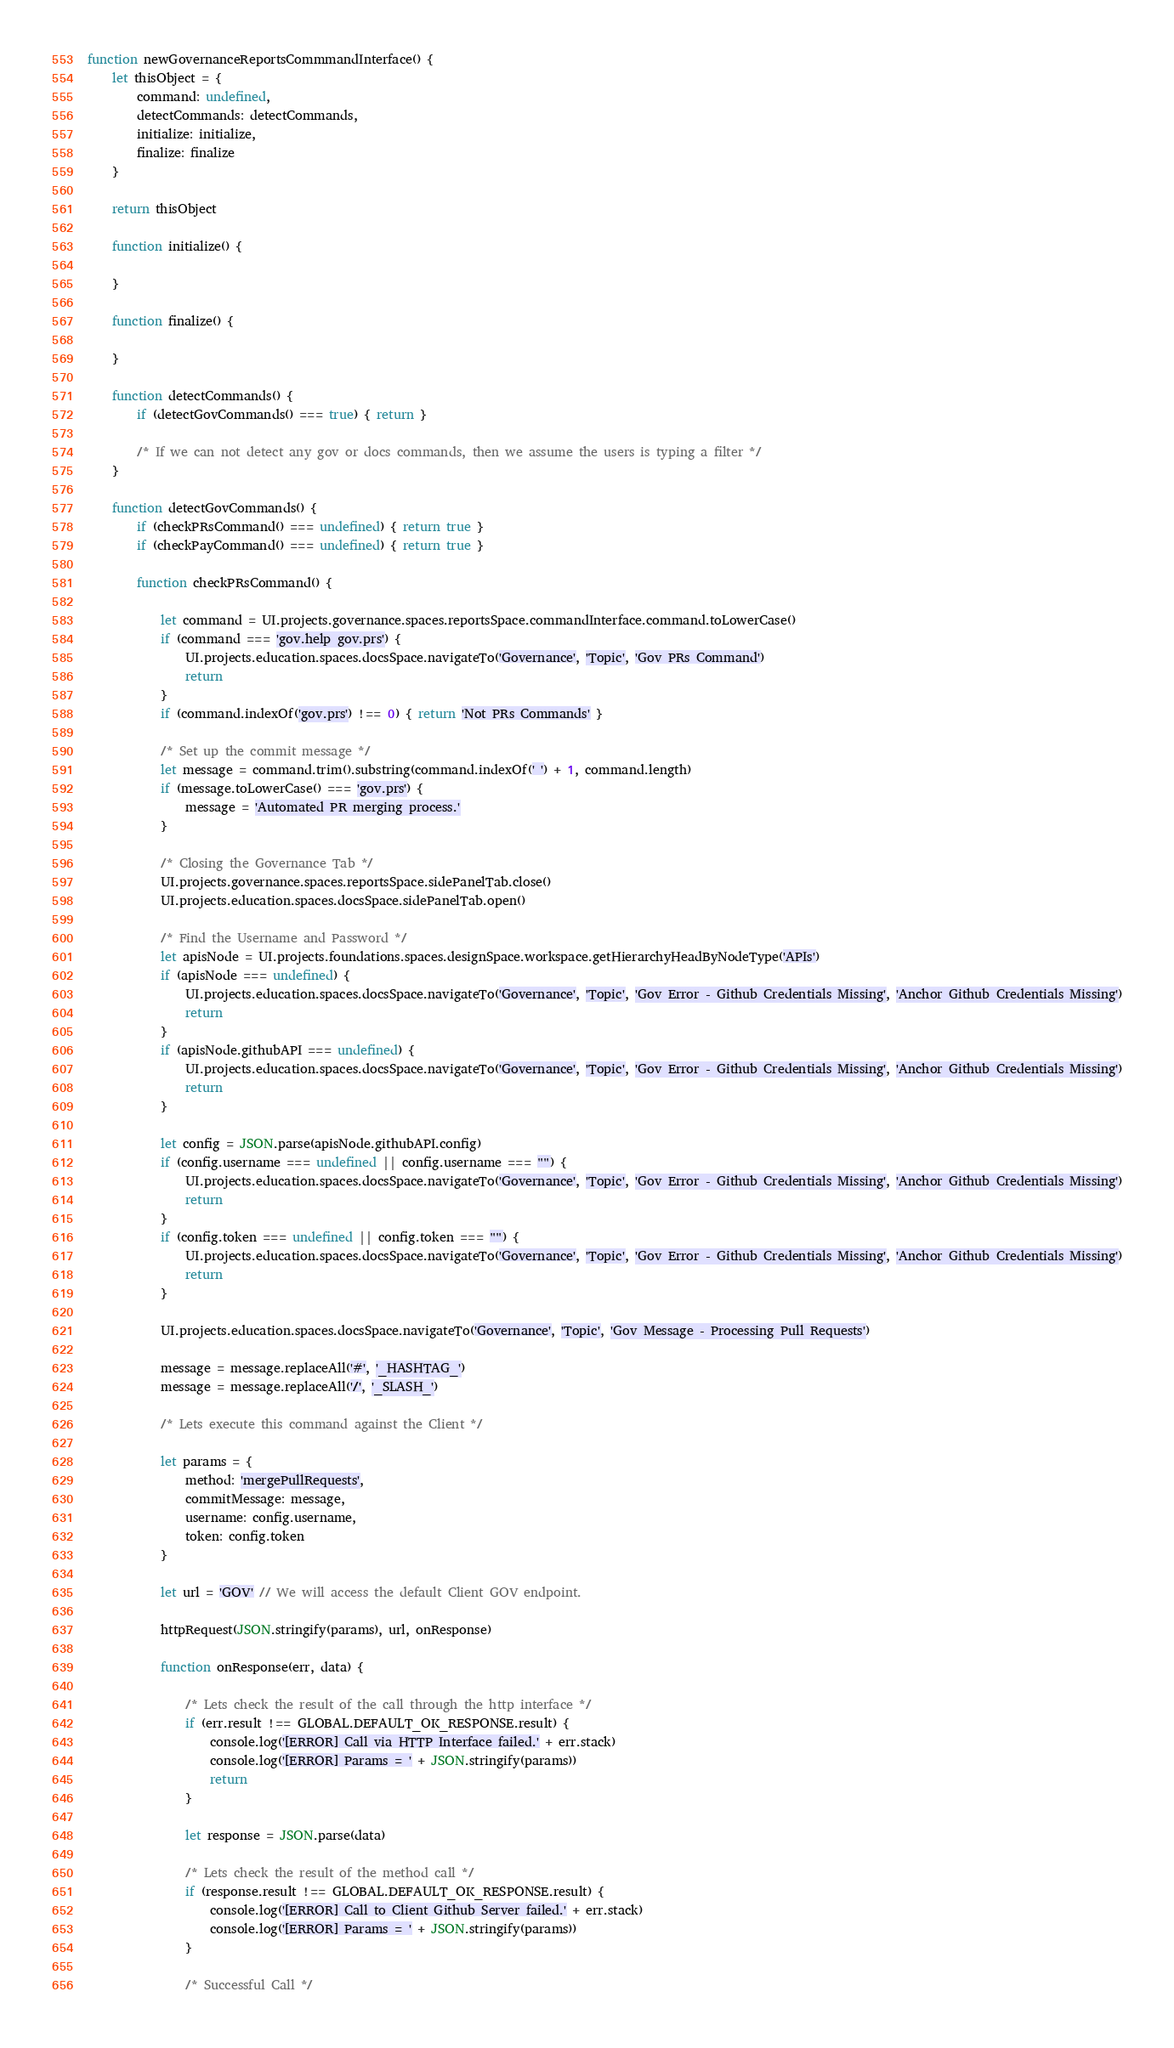<code> <loc_0><loc_0><loc_500><loc_500><_JavaScript_>function newGovernanceReportsCommmandInterface() {
    let thisObject = {
        command: undefined,
        detectCommands: detectCommands,
        initialize: initialize,
        finalize: finalize
    }

    return thisObject

    function initialize() {

    }

    function finalize() {

    }

    function detectCommands() {
        if (detectGovCommands() === true) { return }

        /* If we can not detect any gov or docs commands, then we assume the users is typing a filter */
    }

    function detectGovCommands() {
        if (checkPRsCommand() === undefined) { return true }
        if (checkPayCommand() === undefined) { return true }

        function checkPRsCommand() {

            let command = UI.projects.governance.spaces.reportsSpace.commandInterface.command.toLowerCase()
            if (command === 'gov.help gov.prs') {
                UI.projects.education.spaces.docsSpace.navigateTo('Governance', 'Topic', 'Gov PRs Command')
                return
            }
            if (command.indexOf('gov.prs') !== 0) { return 'Not PRs Commands' }

            /* Set up the commit message */
            let message = command.trim().substring(command.indexOf(' ') + 1, command.length)
            if (message.toLowerCase() === 'gov.prs') {
                message = 'Automated PR merging process.'
            }

            /* Closing the Governance Tab */
            UI.projects.governance.spaces.reportsSpace.sidePanelTab.close()
            UI.projects.education.spaces.docsSpace.sidePanelTab.open()

            /* Find the Username and Password */
            let apisNode = UI.projects.foundations.spaces.designSpace.workspace.getHierarchyHeadByNodeType('APIs')
            if (apisNode === undefined) {
                UI.projects.education.spaces.docsSpace.navigateTo('Governance', 'Topic', 'Gov Error - Github Credentials Missing', 'Anchor Github Credentials Missing')
                return
            }
            if (apisNode.githubAPI === undefined) {
                UI.projects.education.spaces.docsSpace.navigateTo('Governance', 'Topic', 'Gov Error - Github Credentials Missing', 'Anchor Github Credentials Missing')
                return
            }

            let config = JSON.parse(apisNode.githubAPI.config)
            if (config.username === undefined || config.username === "") {
                UI.projects.education.spaces.docsSpace.navigateTo('Governance', 'Topic', 'Gov Error - Github Credentials Missing', 'Anchor Github Credentials Missing')
                return
            }
            if (config.token === undefined || config.token === "") {
                UI.projects.education.spaces.docsSpace.navigateTo('Governance', 'Topic', 'Gov Error - Github Credentials Missing', 'Anchor Github Credentials Missing')
                return
            }

            UI.projects.education.spaces.docsSpace.navigateTo('Governance', 'Topic', 'Gov Message - Processing Pull Requests')

            message = message.replaceAll('#', '_HASHTAG_')
            message = message.replaceAll('/', '_SLASH_')

            /* Lets execute this command against the Client */

            let params = {
                method: 'mergePullRequests',
                commitMessage: message,
                username: config.username,
                token: config.token
            }

            let url = 'GOV' // We will access the default Client GOV endpoint.

            httpRequest(JSON.stringify(params), url, onResponse)

            function onResponse(err, data) {

                /* Lets check the result of the call through the http interface */
                if (err.result !== GLOBAL.DEFAULT_OK_RESPONSE.result) {
                    console.log('[ERROR] Call via HTTP Interface failed.' + err.stack)
                    console.log('[ERROR] Params = ' + JSON.stringify(params))
                    return
                }

                let response = JSON.parse(data)

                /* Lets check the result of the method call */
                if (response.result !== GLOBAL.DEFAULT_OK_RESPONSE.result) {
                    console.log('[ERROR] Call to Client Github Server failed.' + err.stack)
                    console.log('[ERROR] Params = ' + JSON.stringify(params))
                }

                /* Successful Call */
</code> 